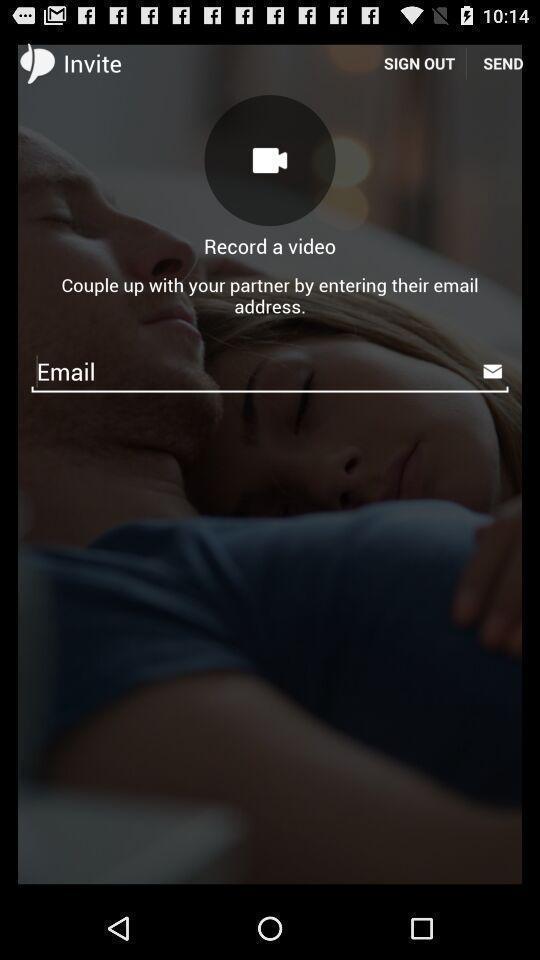Describe the content in this image. Sign in page of an account. 